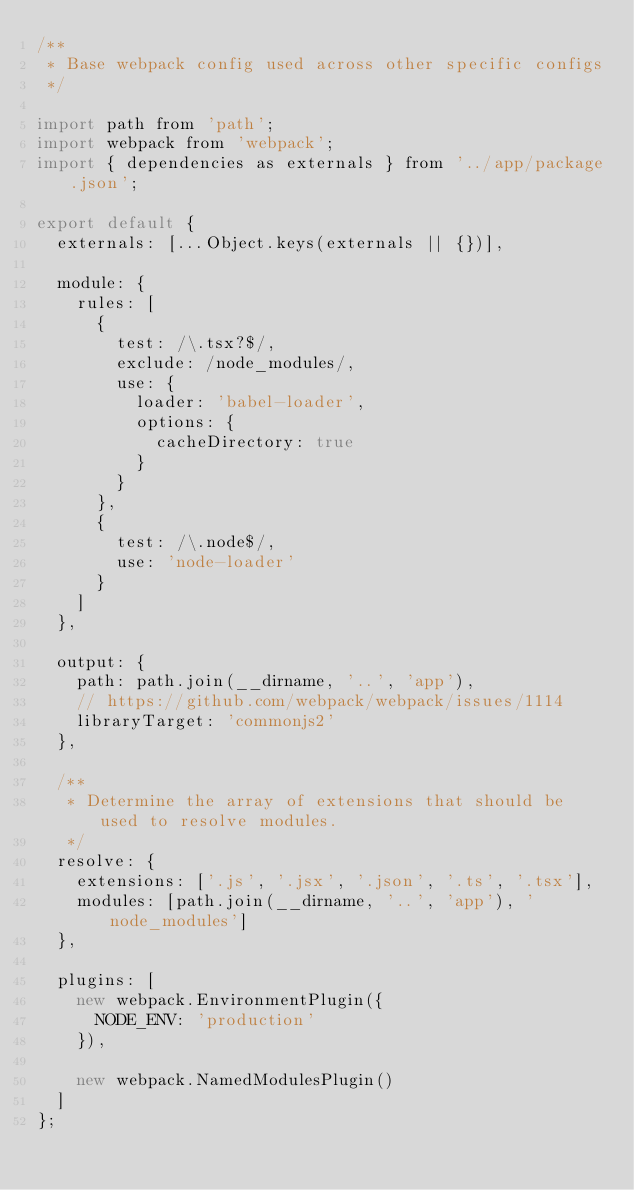<code> <loc_0><loc_0><loc_500><loc_500><_JavaScript_>/**
 * Base webpack config used across other specific configs
 */

import path from 'path';
import webpack from 'webpack';
import { dependencies as externals } from '../app/package.json';

export default {
  externals: [...Object.keys(externals || {})],

  module: {
    rules: [
      {
        test: /\.tsx?$/,
        exclude: /node_modules/,
        use: {
          loader: 'babel-loader',
          options: {
            cacheDirectory: true
          }
        }
      },
      {
        test: /\.node$/,
        use: 'node-loader'
      }
    ]
  },

  output: {
    path: path.join(__dirname, '..', 'app'),
    // https://github.com/webpack/webpack/issues/1114
    libraryTarget: 'commonjs2'
  },

  /**
   * Determine the array of extensions that should be used to resolve modules.
   */
  resolve: {
    extensions: ['.js', '.jsx', '.json', '.ts', '.tsx'],
    modules: [path.join(__dirname, '..', 'app'), 'node_modules']
  },

  plugins: [
    new webpack.EnvironmentPlugin({
      NODE_ENV: 'production'
    }),

    new webpack.NamedModulesPlugin()
  ]
};
</code> 